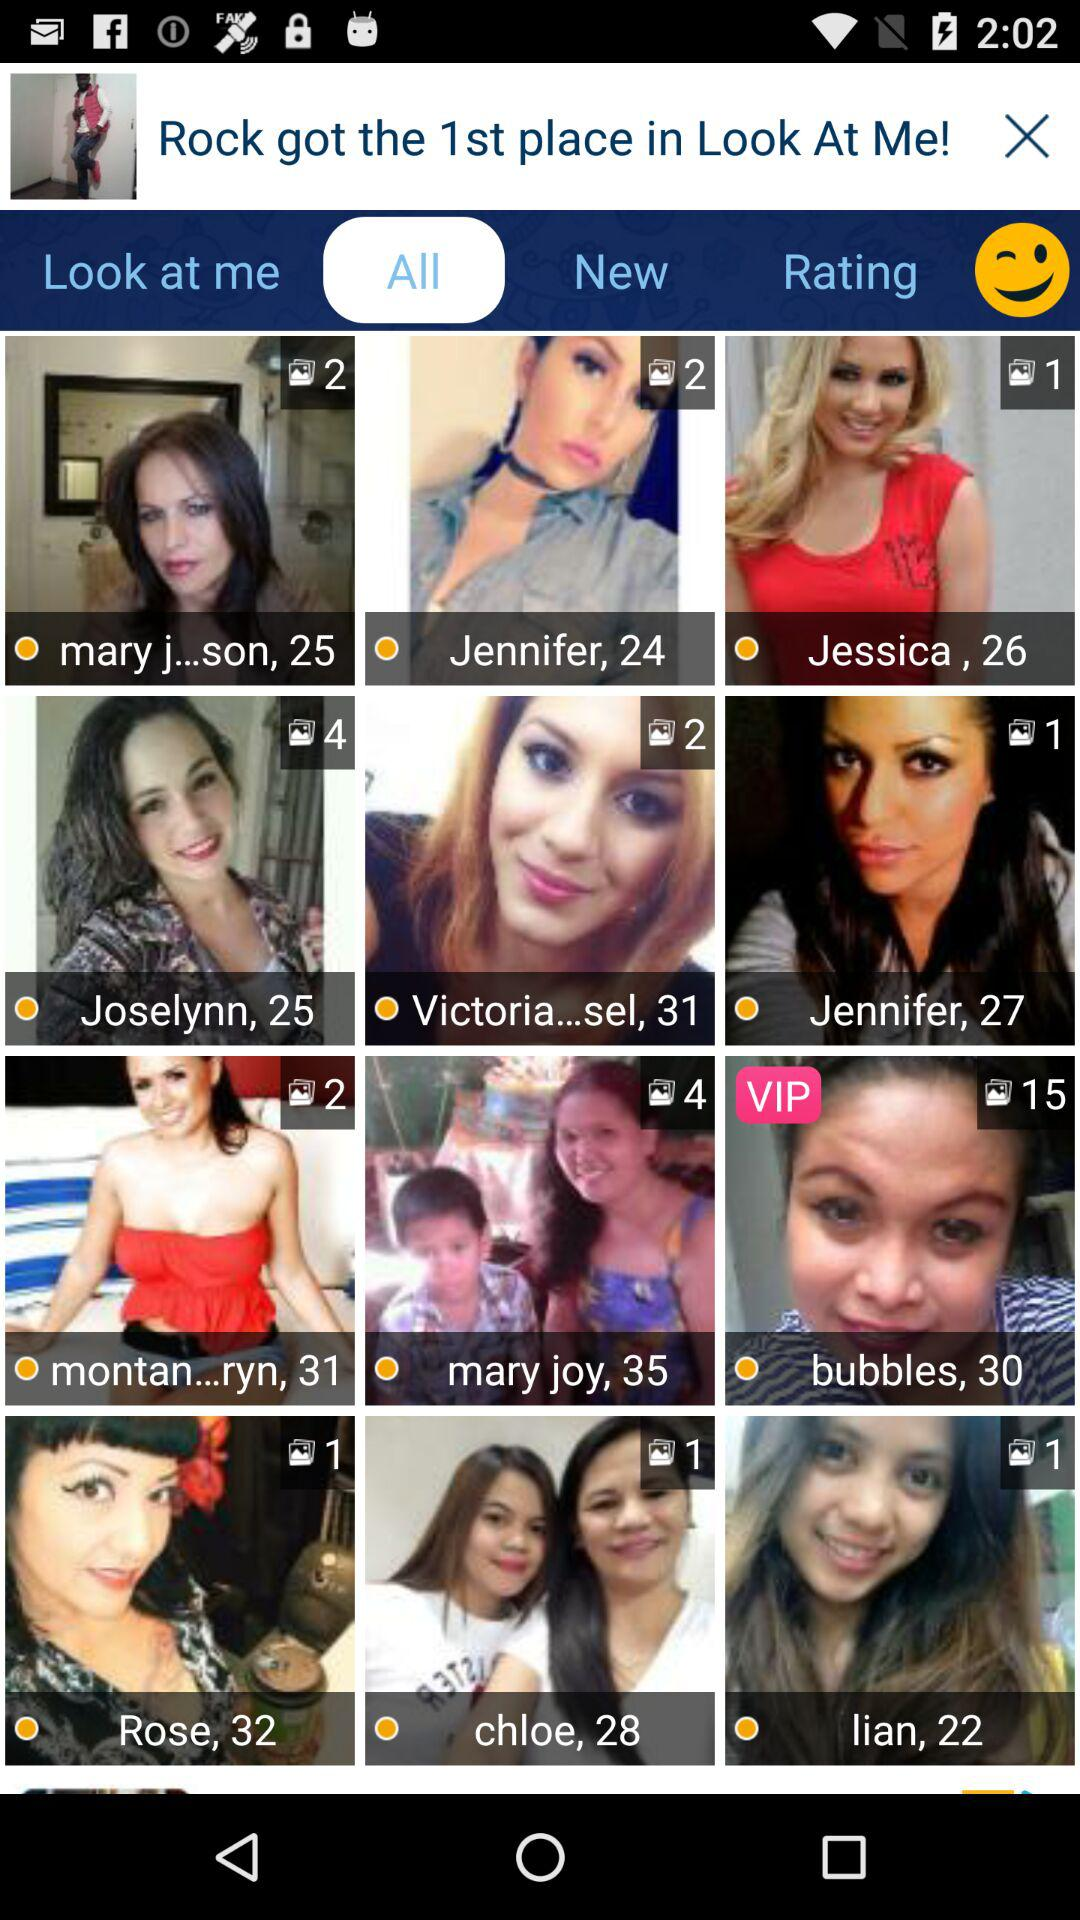Who is the VIP on the list? The VIP on the list is "bubbles". 